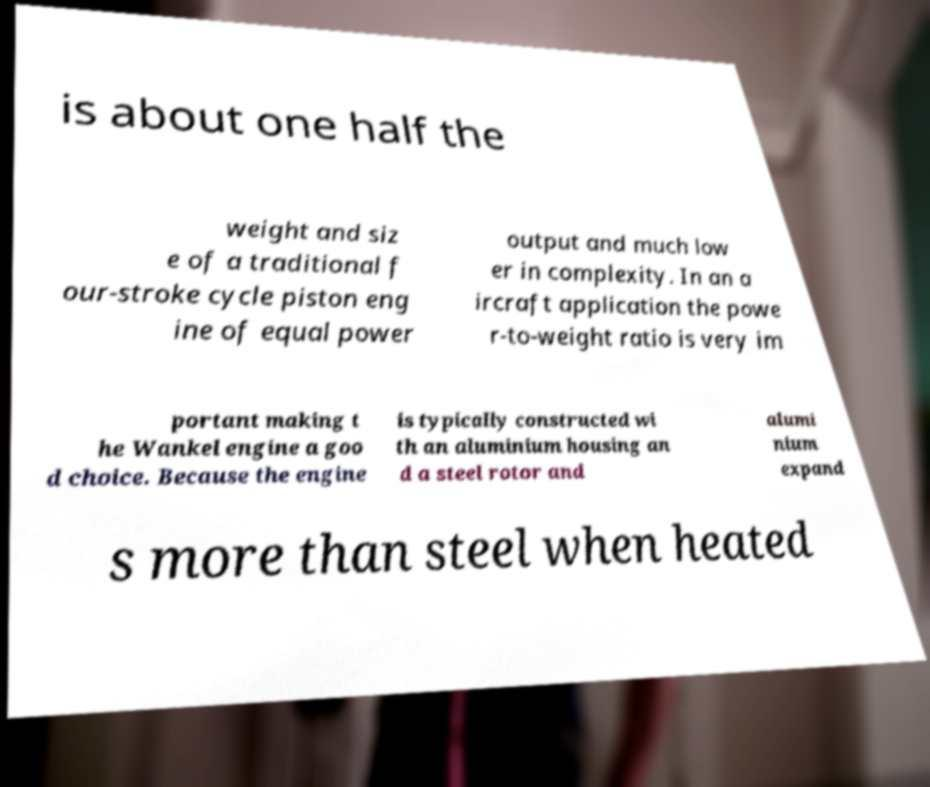What messages or text are displayed in this image? I need them in a readable, typed format. is about one half the weight and siz e of a traditional f our-stroke cycle piston eng ine of equal power output and much low er in complexity. In an a ircraft application the powe r-to-weight ratio is very im portant making t he Wankel engine a goo d choice. Because the engine is typically constructed wi th an aluminium housing an d a steel rotor and alumi nium expand s more than steel when heated 